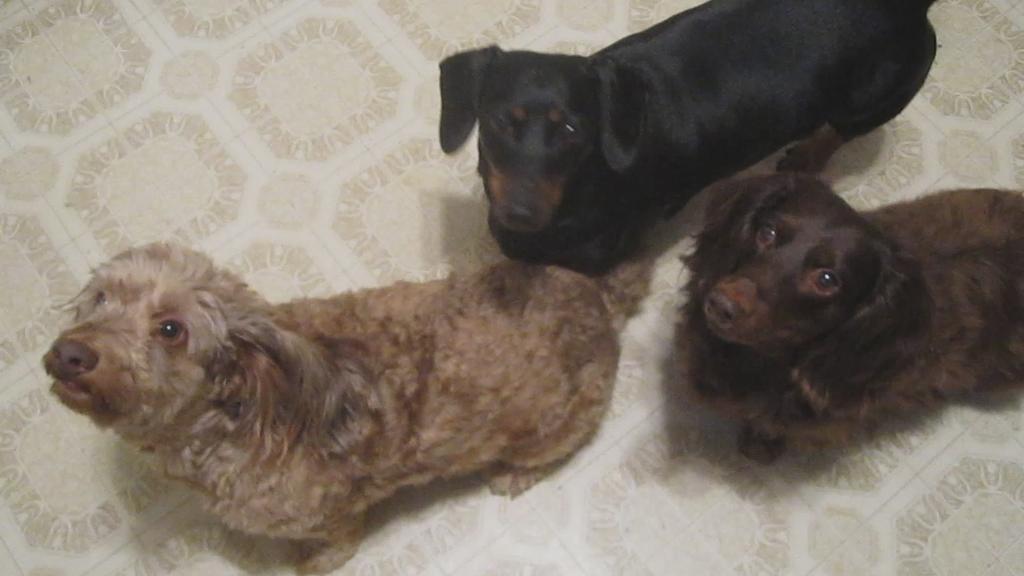Could you give a brief overview of what you see in this image? In this image I can see three dogs. I can see colour of these dogs are brown, black and cream. 